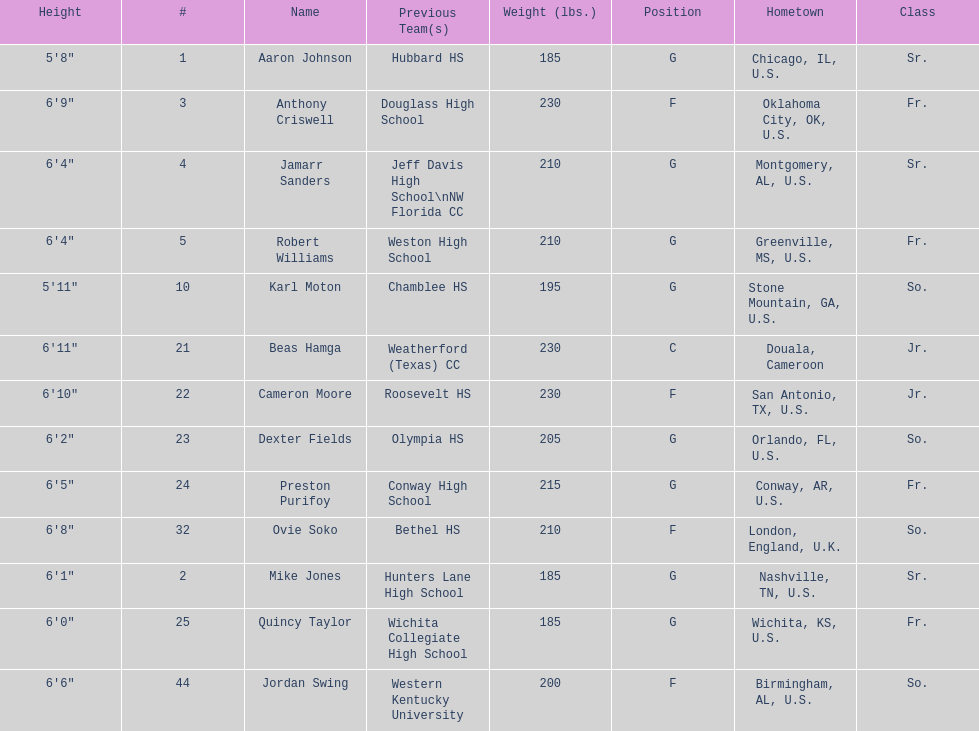Who weighs more, dexter fields or ovie soko? Ovie Soko. Parse the table in full. {'header': ['Height', '#', 'Name', 'Previous Team(s)', 'Weight (lbs.)', 'Position', 'Hometown', 'Class'], 'rows': [['5\'8"', '1', 'Aaron Johnson', 'Hubbard HS', '185', 'G', 'Chicago, IL, U.S.', 'Sr.'], ['6\'9"', '3', 'Anthony Criswell', 'Douglass High School', '230', 'F', 'Oklahoma City, OK, U.S.', 'Fr.'], ['6\'4"', '4', 'Jamarr Sanders', 'Jeff Davis High School\\nNW Florida CC', '210', 'G', 'Montgomery, AL, U.S.', 'Sr.'], ['6\'4"', '5', 'Robert Williams', 'Weston High School', '210', 'G', 'Greenville, MS, U.S.', 'Fr.'], ['5\'11"', '10', 'Karl Moton', 'Chamblee HS', '195', 'G', 'Stone Mountain, GA, U.S.', 'So.'], ['6\'11"', '21', 'Beas Hamga', 'Weatherford (Texas) CC', '230', 'C', 'Douala, Cameroon', 'Jr.'], ['6\'10"', '22', 'Cameron Moore', 'Roosevelt HS', '230', 'F', 'San Antonio, TX, U.S.', 'Jr.'], ['6\'2"', '23', 'Dexter Fields', 'Olympia HS', '205', 'G', 'Orlando, FL, U.S.', 'So.'], ['6\'5"', '24', 'Preston Purifoy', 'Conway High School', '215', 'G', 'Conway, AR, U.S.', 'Fr.'], ['6\'8"', '32', 'Ovie Soko', 'Bethel HS', '210', 'F', 'London, England, U.K.', 'So.'], ['6\'1"', '2', 'Mike Jones', 'Hunters Lane High School', '185', 'G', 'Nashville, TN, U.S.', 'Sr.'], ['6\'0"', '25', 'Quincy Taylor', 'Wichita Collegiate High School', '185', 'G', 'Wichita, KS, U.S.', 'Fr.'], ['6\'6"', '44', 'Jordan Swing', 'Western Kentucky University', '200', 'F', 'Birmingham, AL, U.S.', 'So.']]} 